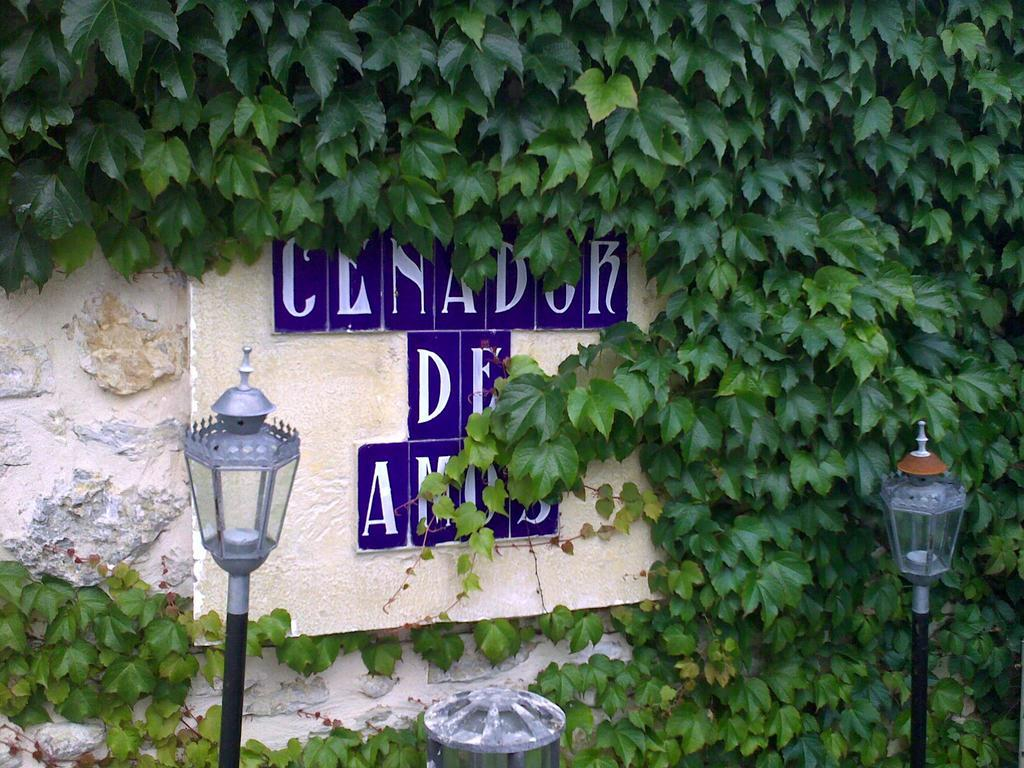What type of structures can be seen in the image? There are light poles in the image. What is attached to the stone wall in the image? There is a board on a stone wall in the image. What color are the letters on the board? The letters on the board have a blue color. What type of vegetation can be seen in the image? There are creepers visible in the image. How many women are present in the image? There are no women present in the image. What type of thing is the manager using to communicate in the image? There is no manager or communication device present in the image. 